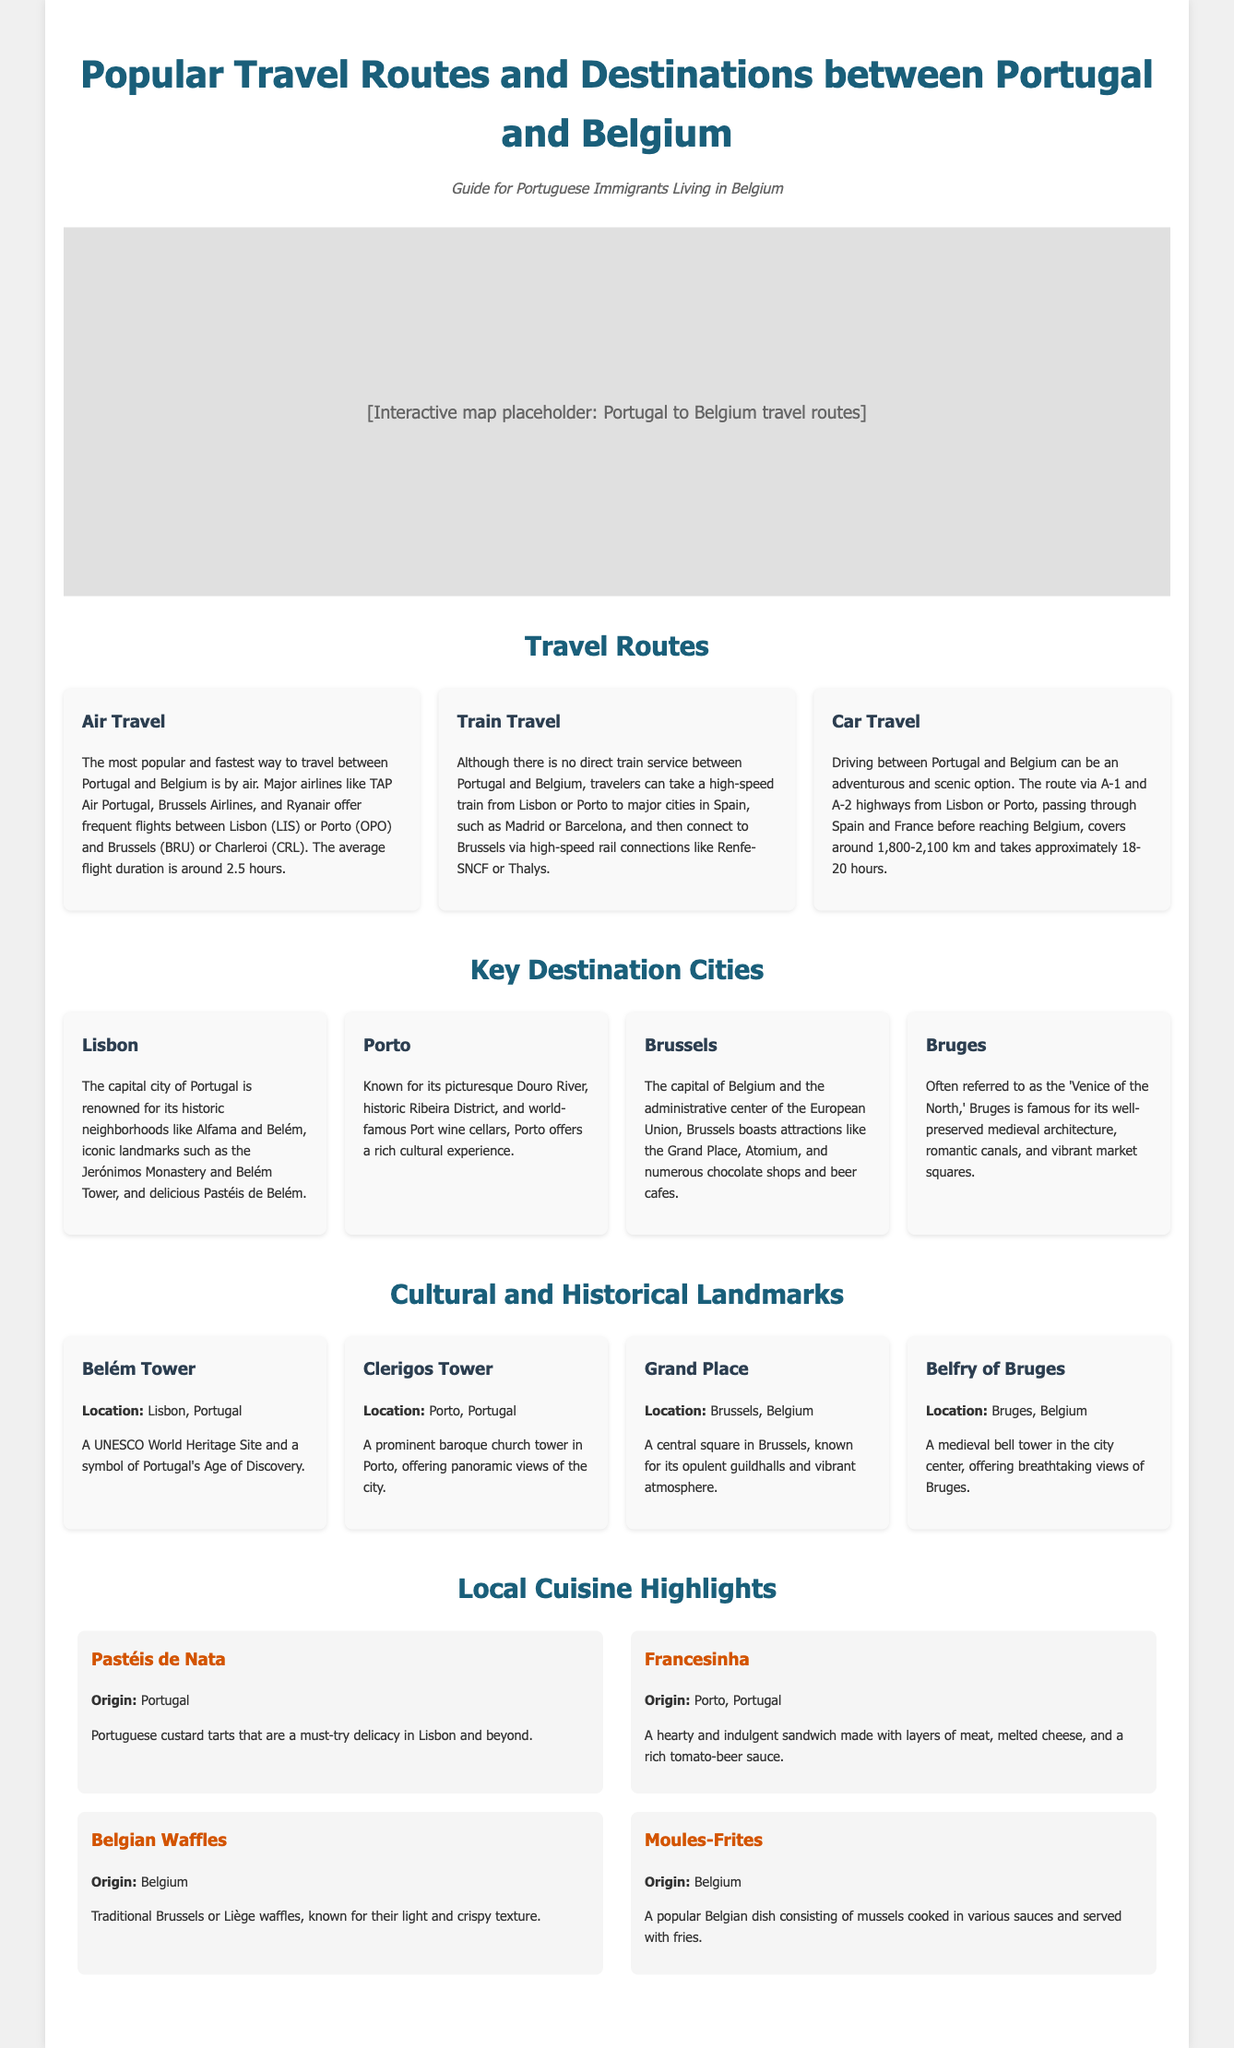What is the average flight duration from Portugal to Belgium? The average flight duration is mentioned in the document as around 2.5 hours.
Answer: 2.5 hours Which airline is NOT mentioned as offering flights between Portugal and Belgium? The document lists TAP Air Portugal, Brussels Airlines, and Ryanair as major airlines. Therefore, any airline not mentioned from this list is correct.
Answer: Example: KLM What highway route is suggested for car travel from Portugal to Belgium? The document states the route via A-1 and A-2 highways is used when driving from Portugal to Belgium.
Answer: A-1 and A-2 highways Name a city in Belgium that is highlighted as a key destination. The document mentions Brussels and Bruges as key destination cities in Belgium.
Answer: Brussels What dish is a must-try delicacy in Lisbon? The document specifies Pastéis de Nata as the must-try delicacy in Lisbon.
Answer: Pastéis de Nata How long does the car travel from Portugal to Belgium approximately take? The document indicates that the driving time takes approximately 18-20 hours.
Answer: 18-20 hours Which tower is a prominent baroque church tower in Porto? The document refers to Clerigos Tower as the prominent baroque church tower.
Answer: Clerigos Tower What type of travel does the document label as the fastest way to travel to Belgium? The document clearly defines air travel as the fastest way.
Answer: Air Travel 